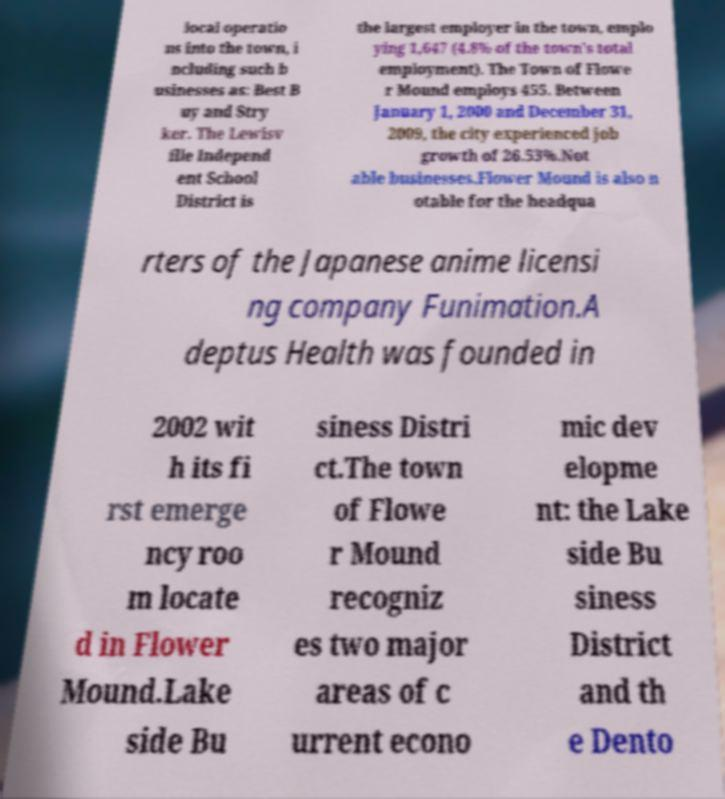What messages or text are displayed in this image? I need them in a readable, typed format. local operatio ns into the town, i ncluding such b usinesses as: Best B uy and Stry ker. The Lewisv ille Independ ent School District is the largest employer in the town, emplo ying 1,647 (4.8% of the town's total employment). The Town of Flowe r Mound employs 455. Between January 1, 2000 and December 31, 2009, the city experienced job growth of 26.53%.Not able businesses.Flower Mound is also n otable for the headqua rters of the Japanese anime licensi ng company Funimation.A deptus Health was founded in 2002 wit h its fi rst emerge ncy roo m locate d in Flower Mound.Lake side Bu siness Distri ct.The town of Flowe r Mound recogniz es two major areas of c urrent econo mic dev elopme nt: the Lake side Bu siness District and th e Dento 